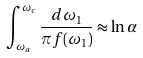Convert formula to latex. <formula><loc_0><loc_0><loc_500><loc_500>\int _ { \omega _ { a } } ^ { \omega _ { c } } \frac { d \omega _ { 1 } } { \pi f ( \omega _ { 1 } ) } \approx \ln \alpha</formula> 